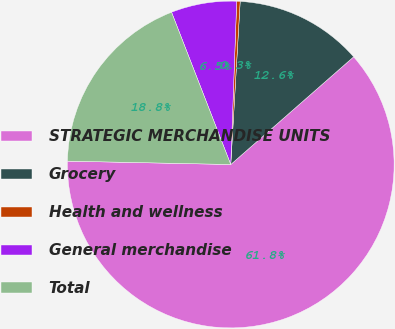Convert chart. <chart><loc_0><loc_0><loc_500><loc_500><pie_chart><fcel>STRATEGIC MERCHANDISE UNITS<fcel>Grocery<fcel>Health and wellness<fcel>General merchandise<fcel>Total<nl><fcel>61.78%<fcel>12.63%<fcel>0.34%<fcel>6.48%<fcel>18.77%<nl></chart> 